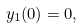Convert formula to latex. <formula><loc_0><loc_0><loc_500><loc_500>y _ { 1 } ( 0 ) = 0 ,</formula> 